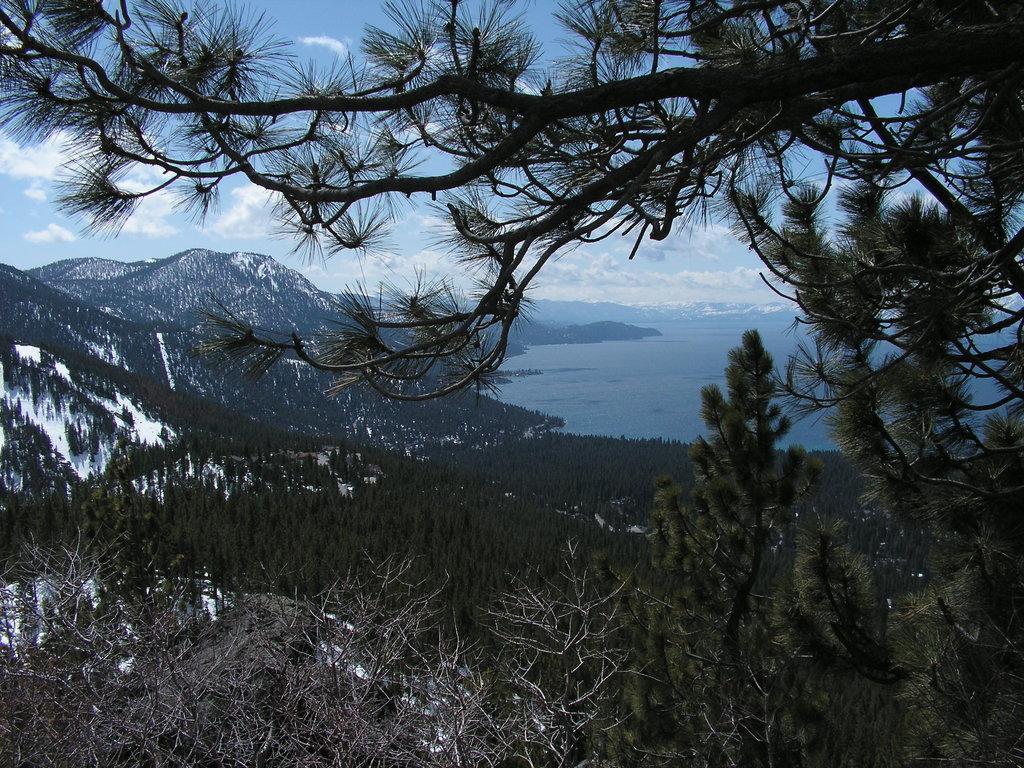Describe this image in one or two sentences. In this picture we can see trees, on the right side there is water, in the background we can see hills, there is the sky and clouds at the top of the picture. 